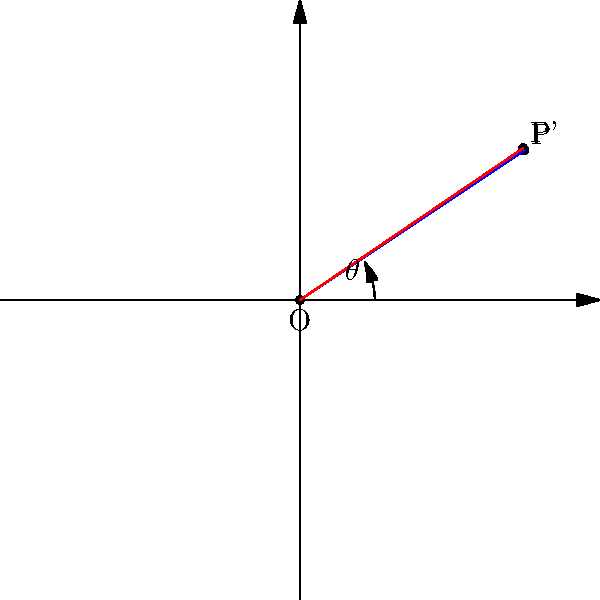Given a point $P(3,2)$ in a 2D coordinate system and a counterclockwise rotation of $\frac{\pi}{6}$ radians about the origin, determine the coordinates of the rotated point $P'$ using the rotation matrix. Round your answer to two decimal places. To solve this problem, we'll follow these steps:

1) The rotation matrix for a counterclockwise rotation by angle $\theta$ is:

   $$R(\theta) = \begin{bmatrix} \cos\theta & -\sin\theta \\ \sin\theta & \cos\theta \end{bmatrix}$$

2) In this case, $\theta = \frac{\pi}{6}$. Let's calculate $\cos\frac{\pi}{6}$ and $\sin\frac{\pi}{6}$:

   $\cos\frac{\pi}{6} = \frac{\sqrt{3}}{2}$
   $\sin\frac{\pi}{6} = \frac{1}{2}$

3) Substituting these values into the rotation matrix:

   $$R(\frac{\pi}{6}) = \begin{bmatrix} \frac{\sqrt{3}}{2} & -\frac{1}{2} \\ \frac{1}{2} & \frac{\sqrt{3}}{2} \end{bmatrix}$$

4) To rotate the point $P(3,2)$, we multiply the rotation matrix by the column vector of $P$:

   $$P' = R(\frac{\pi}{6}) \cdot \begin{bmatrix} 3 \\ 2 \end{bmatrix}$$

5) Performing the matrix multiplication:

   $$\begin{bmatrix} \frac{\sqrt{3}}{2} & -\frac{1}{2} \\ \frac{1}{2} & \frac{\sqrt{3}}{2} \end{bmatrix} \cdot \begin{bmatrix} 3 \\ 2 \end{bmatrix} = \begin{bmatrix} \frac{3\sqrt{3}}{2} - 1 \\ \frac{3}{2} + \sqrt{3} \end{bmatrix}$$

6) Simplifying and calculating the decimal approximations:

   $x' = \frac{3\sqrt{3}}{2} - 1 \approx 2.5981$
   $y' = \frac{3}{2} + \sqrt{3} \approx 3.2321$

7) Rounding to two decimal places:

   $P' \approx (2.60, 3.23)$
Answer: (2.60, 3.23) 